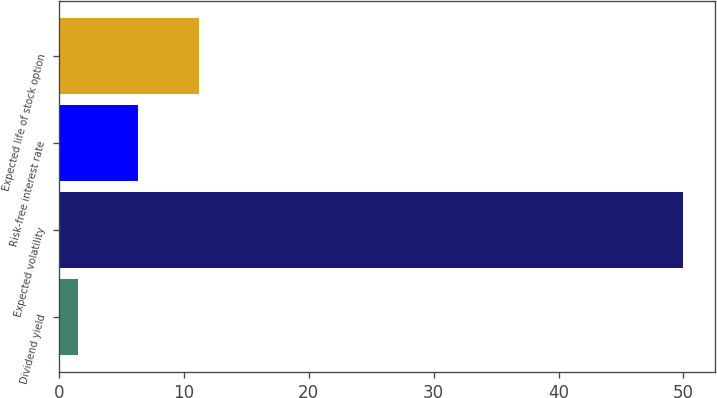Convert chart. <chart><loc_0><loc_0><loc_500><loc_500><bar_chart><fcel>Dividend yield<fcel>Expected volatility<fcel>Risk-free interest rate<fcel>Expected life of stock option<nl><fcel>1.5<fcel>50<fcel>6.35<fcel>11.2<nl></chart> 